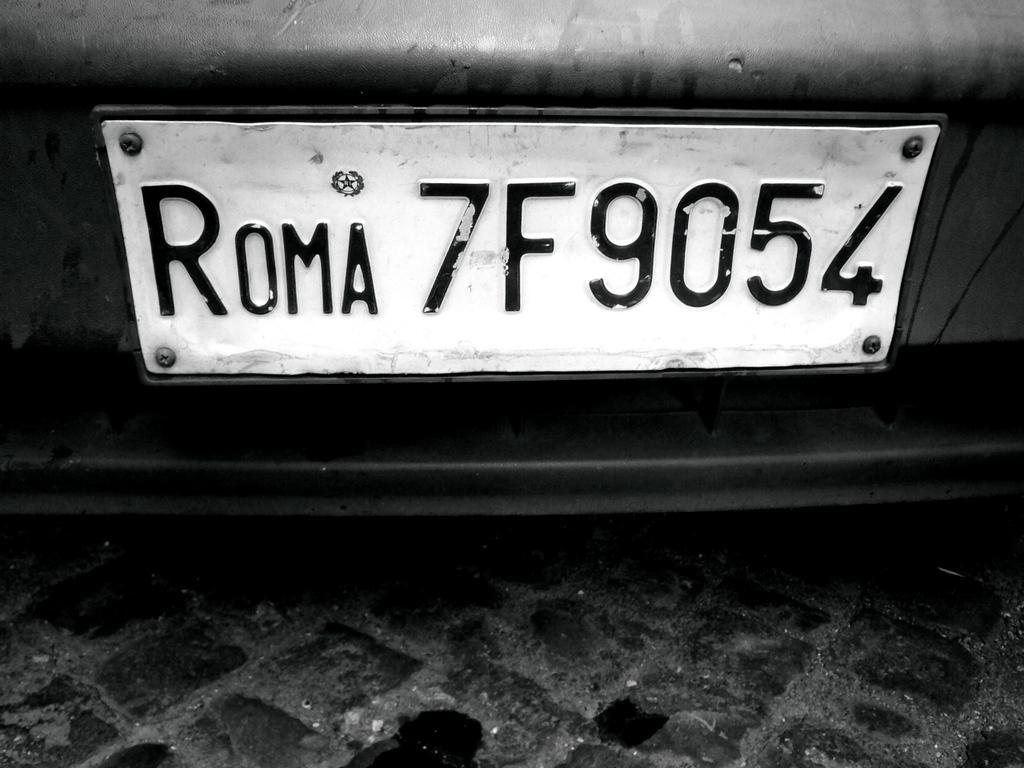Provide a one-sentence caption for the provided image. An Italian license plate in black and white that says ROMA 7F9054. 